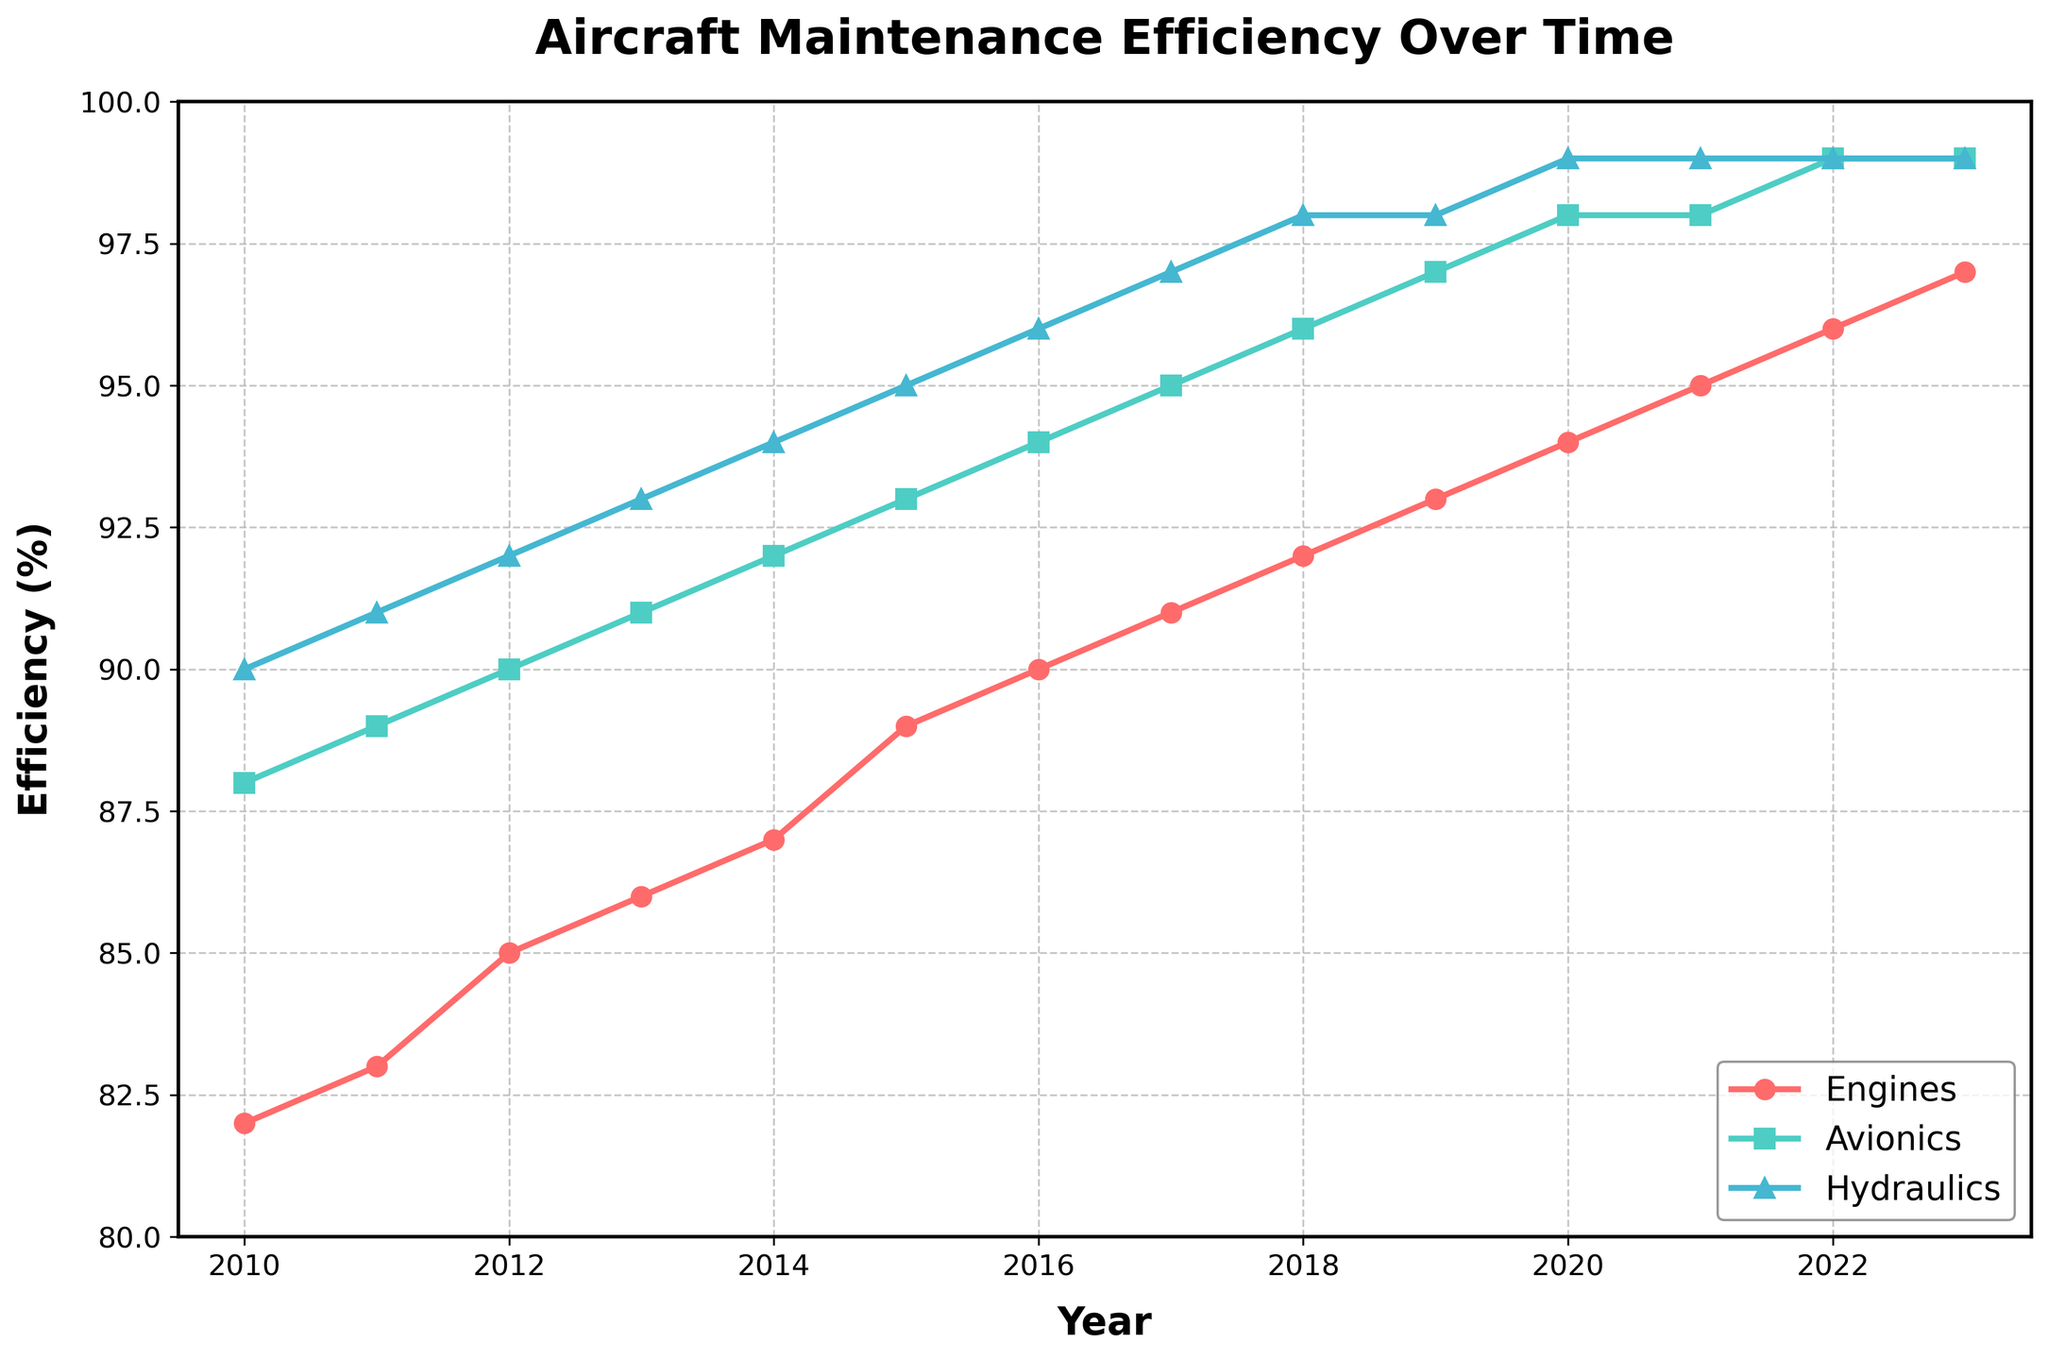What's the trend in the efficiency of the Engines system from 2010 to 2023? The line chart shows a consistent upward trend in the efficiency of Engines from 2010 (82%) to 2023 (97%), indicating improvement over the years.
Answer: Upward Which system showed the highest efficiency in 2014? Look at the lines for Engines, Avionics, and Hydraulics in the year 2014. Hydraulics has the highest value at 94%.
Answer: Hydraulics By how many percentage points did the efficiency of Avionics improve from 2016 to 2023? In 2016, Avionics was at 94%. By 2023, it increased to 99%. The improvement is 99% - 94% = 5 percentage points.
Answer: 5 Which system experienced the smallest increase in efficiency from 2010 to 2023? Calculate the difference for each system from 2010 to 2023: Engines (97-82=15), Avionics (99-88=11), Hydraulics (99-90=9). Hydraulics had the smallest increase of 9 points.
Answer: Hydraulics Which system consistently maintained a higher efficiency than Engines from 2010 to 2023? Observe the relative positions of the lines over the entire period. Hydraulics consistently maintains a higher efficiency than Engines.
Answer: Hydraulics What is the average efficiency of Hydraulics from 2010 to 2023? Sum up all the efficiency values of Hydraulics from 2010 to 2023 and divide by the number of years (14): (90+91+92+93+94+95+96+97+98+98+99+99+99)/14 = 95.14%.
Answer: 95.14 Which system showed the most improvement in efficiency percentage over the years? Calculate the increases from 2010 to 2023 for each system: Engines (15 points), Avionics (11 points), Hydraulics (9 points). Engines showed the most improvement.
Answer: Engines In which year did Avionics and Hydraulics have the same efficiency? Look at the points where the lines for Avionics and Hydraulics intersect. In 2019, both had an efficiency of 98%.
Answer: 2019 